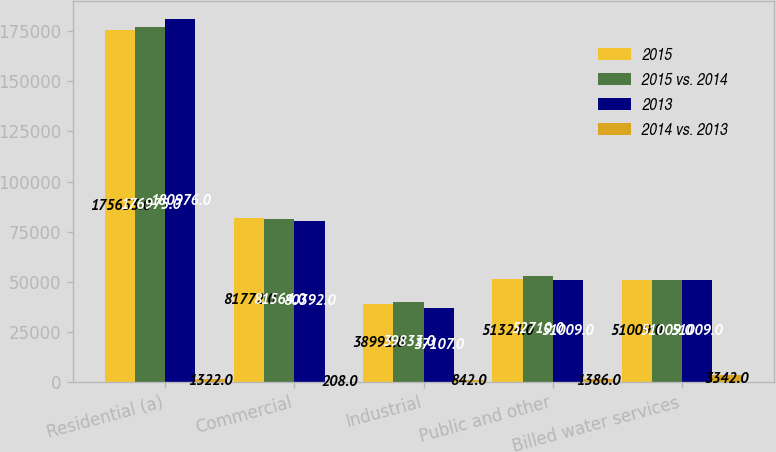Convert chart. <chart><loc_0><loc_0><loc_500><loc_500><stacked_bar_chart><ecel><fcel>Residential (a)<fcel>Commercial<fcel>Industrial<fcel>Public and other<fcel>Billed water services<nl><fcel>2015<fcel>175653<fcel>81772<fcel>38991<fcel>51324<fcel>51009<nl><fcel>2015 vs. 2014<fcel>176975<fcel>81564<fcel>39833<fcel>52710<fcel>51009<nl><fcel>2013<fcel>180976<fcel>80392<fcel>37107<fcel>51009<fcel>51009<nl><fcel>2014 vs. 2013<fcel>1322<fcel>208<fcel>842<fcel>1386<fcel>3342<nl></chart> 